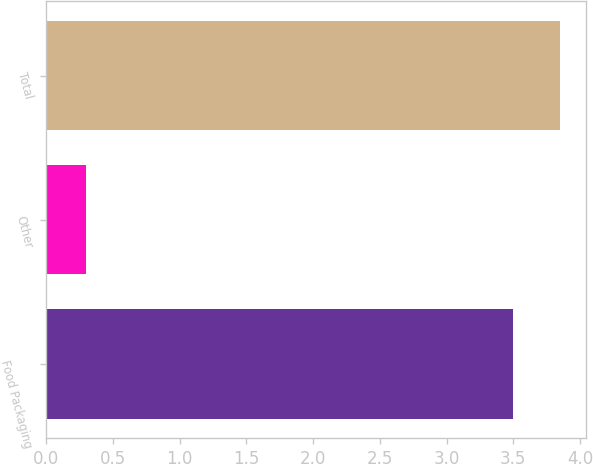Convert chart. <chart><loc_0><loc_0><loc_500><loc_500><bar_chart><fcel>Food Packaging<fcel>Other<fcel>Total<nl><fcel>3.5<fcel>0.3<fcel>3.85<nl></chart> 